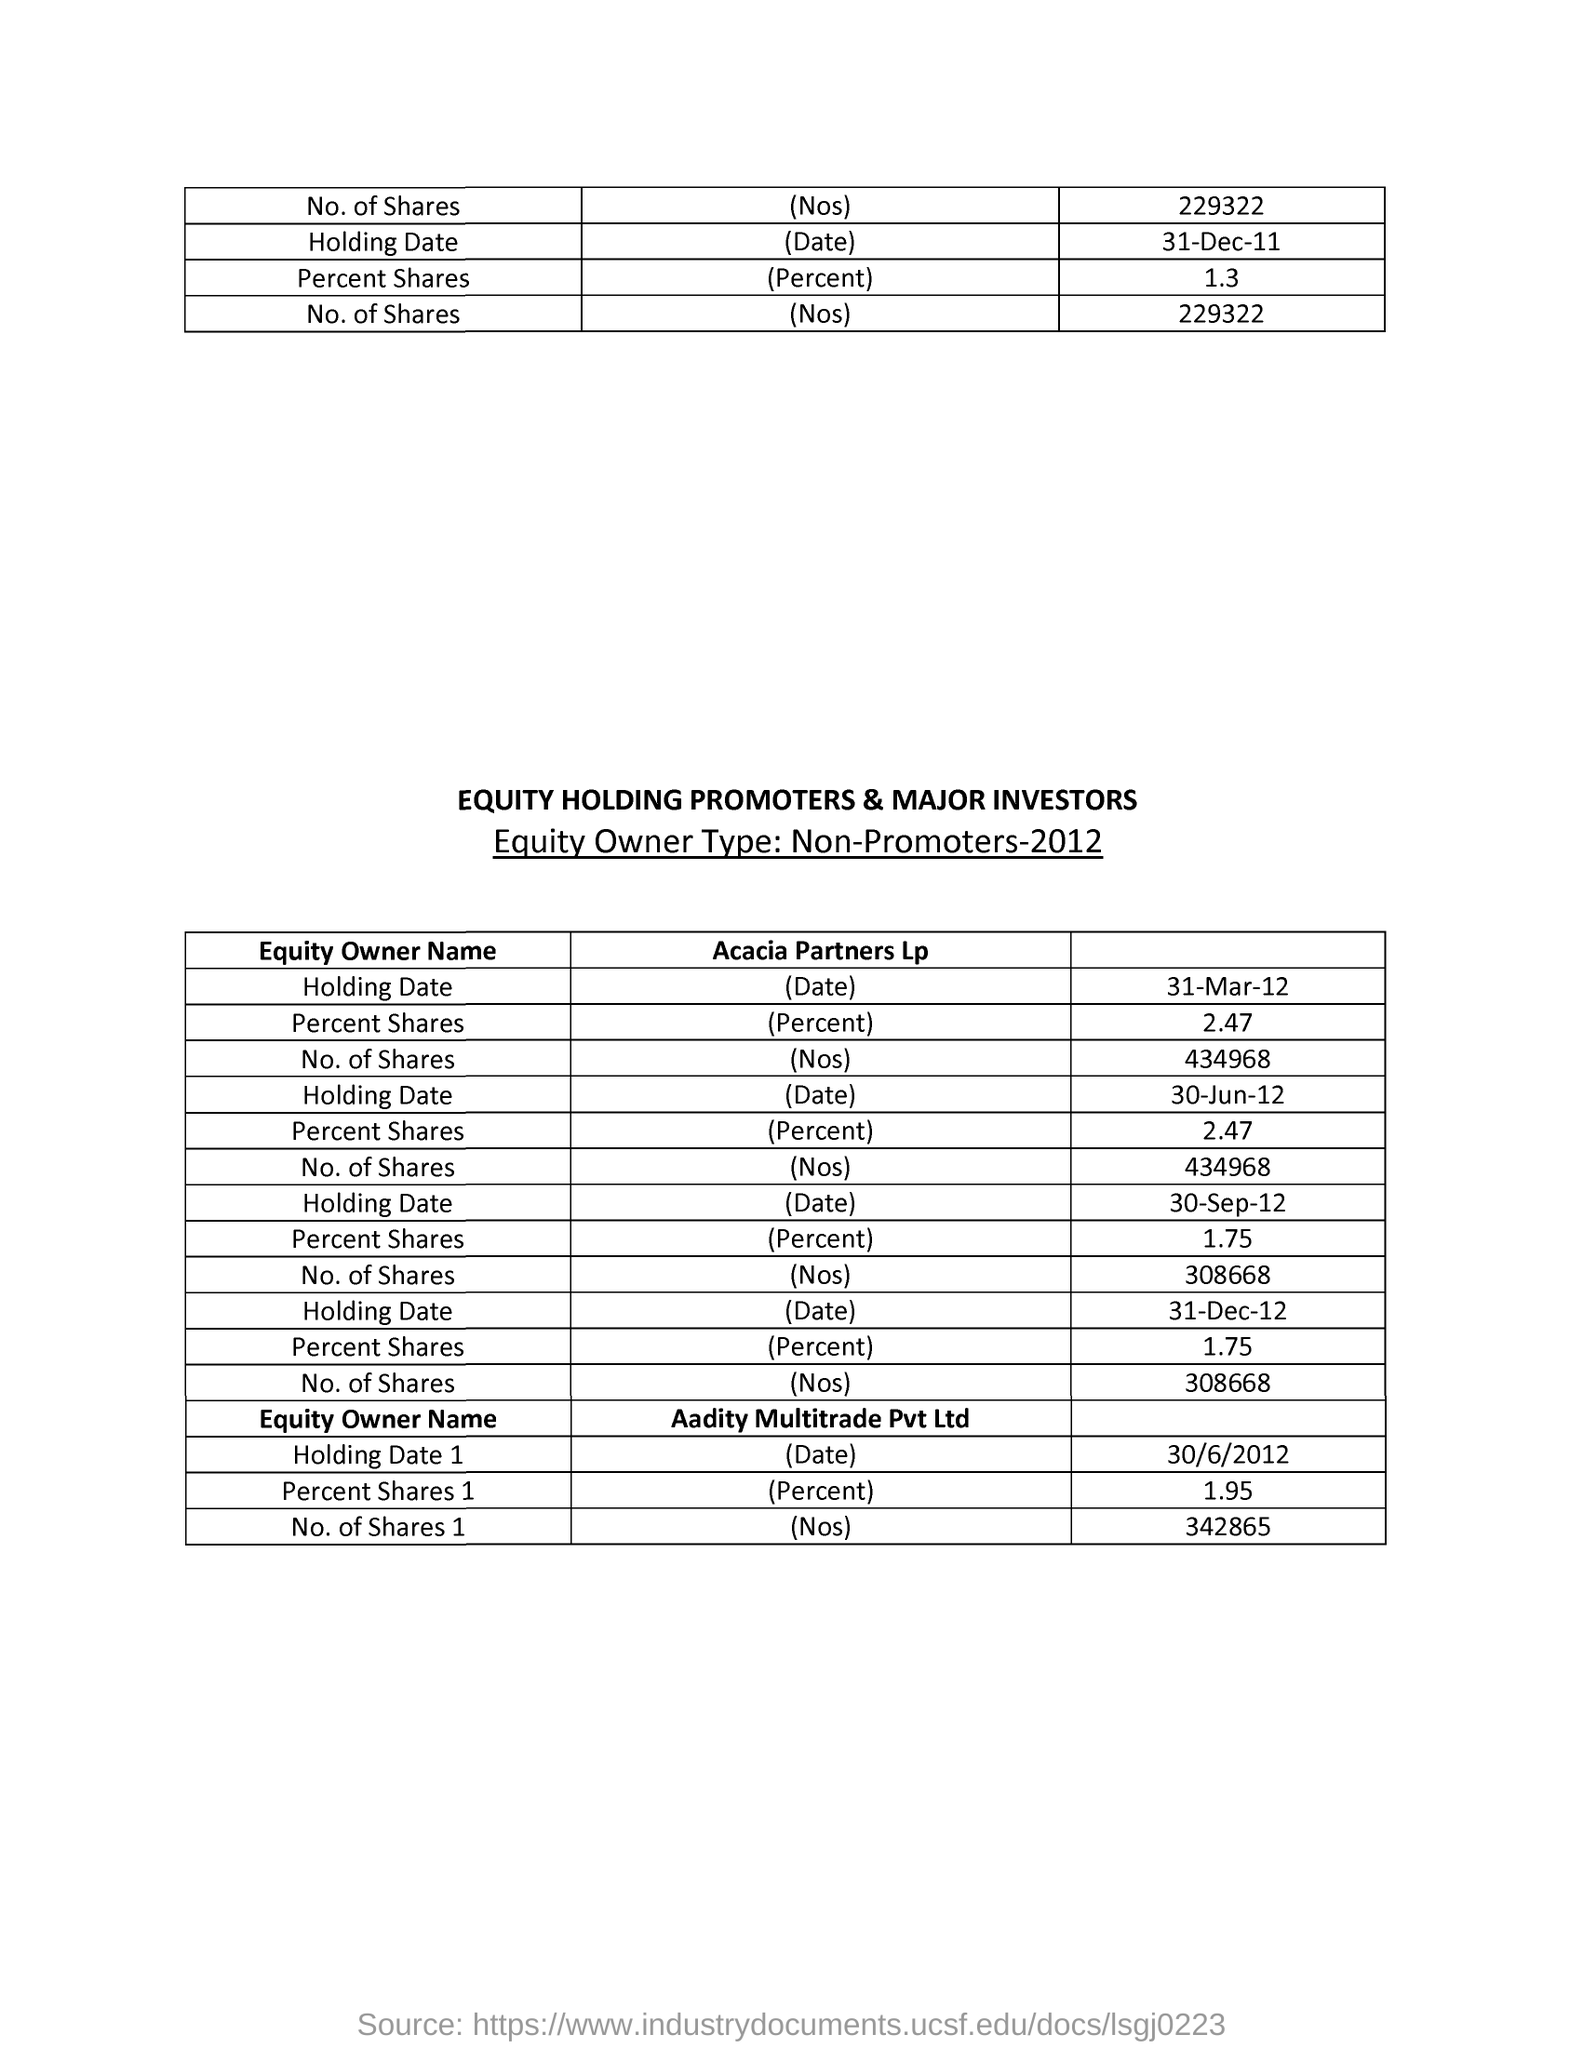Point out several critical features in this image. As of March 31, 2012, Acacia Partners Lp held approximately 2.47% of the outstanding shares of a particular company. On March 31st, 2012, Acacia Partners Lp held a total of 434,968 shares. The percentage of shares held by Aadity Multitrade Pvt Ltd on June 30, 2012 was 1.95%. Acacia Partners Lp held 308,668 shares on December 31, 2012. On December 31st, 2012, Acacia Partners LP held a total of 1.75% of the outstanding shares. 